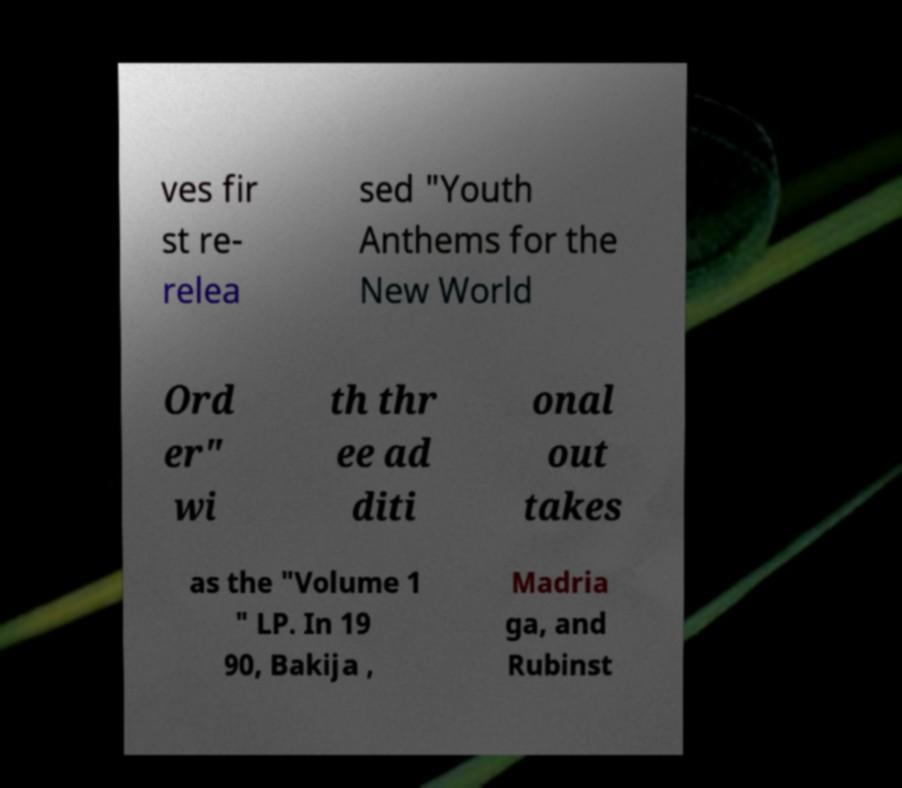For documentation purposes, I need the text within this image transcribed. Could you provide that? ves fir st re- relea sed "Youth Anthems for the New World Ord er" wi th thr ee ad diti onal out takes as the "Volume 1 " LP. In 19 90, Bakija , Madria ga, and Rubinst 